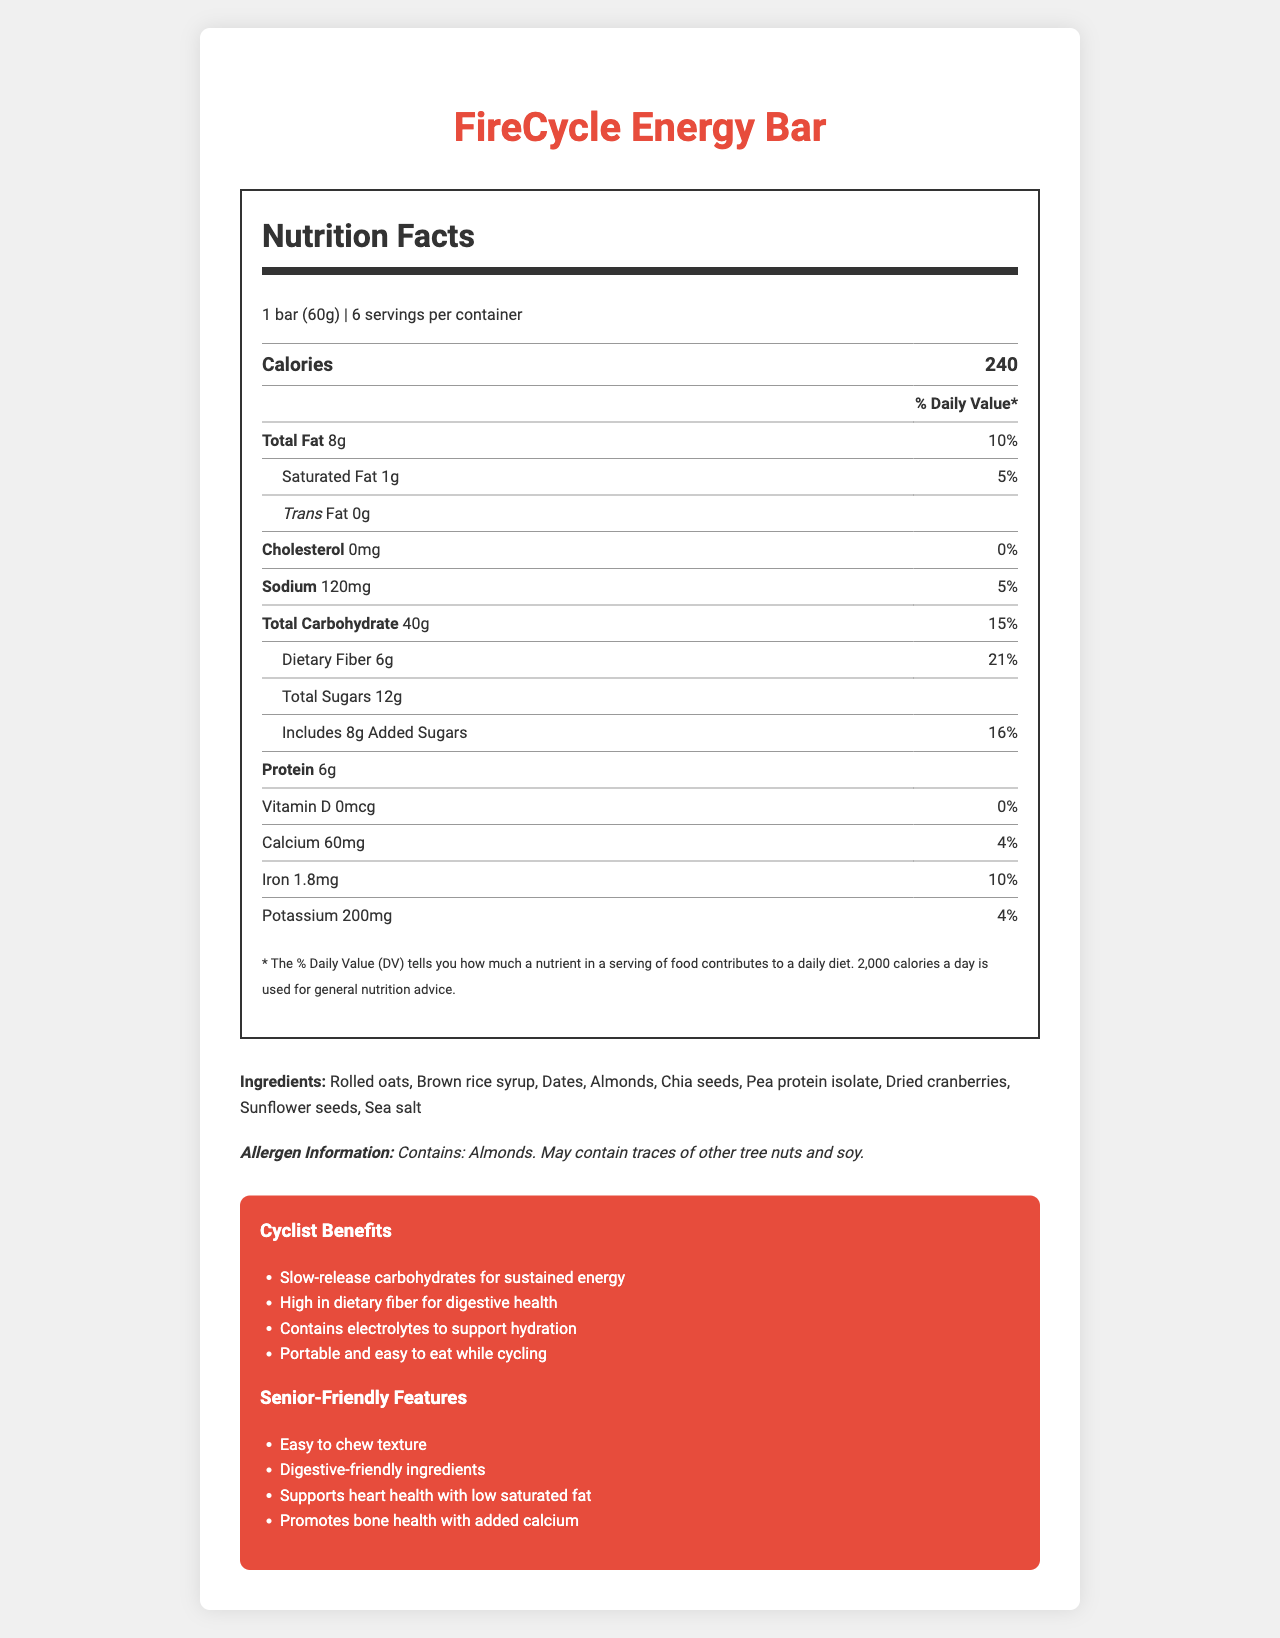what is the serving size for the FireCycle Energy Bar? The serving size is specified at the beginning of the Nutrition Facts section of the document.
Answer: 1 bar (60g) how many servings are in each FireCycle Energy Bar container? The document specifies that there are 6 servings per container.
Answer: 6 what is the total fat amount in one serving of the FireCycle Energy Bar? The total fat per serving is listed as 8g in the nutrition label.
Answer: 8g what percentage of the daily value of dietary fiber does one serving provide? The daily value percentage for dietary fiber is given as 21% in the nutrition label.
Answer: 21% list three main ingredients of the FireCycle Energy Bar. These are the first three ingredients listed in the ingredients section.
Answer: Rolled oats, Brown rice syrup, Dates what is the total carbohydrate content in one serving of the FireCycle Energy Bar? The total carbohydrate content is specified as 40g in the nutrition label.
Answer: 40g how many grams of added sugars are in one serving? The amount of added sugars is listed as 8g in the nutrition label.
Answer: 8g which nutrient in the FireCycle Energy Bar has the highest daily value percentage? A. Protein B. Calcium C. Dietary Fiber D. Iron The percentage daily value for dietary fiber is the highest at 21%.
Answer: C. Dietary Fiber which of the following is NOT an ingredient in the FireCycle Energy Bar? A. Almonds B. Quinoa C. Dates D. Sunflower seeds Quinoa is not listed among the ingredients; the other options are.
Answer: B. Quinoa is the FireCycle Energy Bar gluten-free? The document states that the product is gluten-free in the additional info section.
Answer: Yes does the FireCycle Energy Bar contain any cholesterol? The cholesterol amount is listed as 0mg, indicating there is no cholesterol in the product.
Answer: No summarize the main idea of the document. This summary captures all major sections—nutrition facts, ingredients, allergen info, and benefits—highlighted in the document.
Answer: The document provides detailed nutrition information about the FireCycle Energy Bar, which is a fiber-rich, slow-release carbohydrate snack optimized for long-distance cycling. It includes information about serving size, ingredients, allergen information, and specific benefits for cyclists and seniors. can this energy bar help with hydration during a long-distance cycling event? One of the cyclist benefits mentioned is that the bar contains electrolytes to support hydration, as stated in the additional info section.
Answer: Yes are there any allergens present in the FireCycle Energy Bar? The document mentions that the bar contains almonds and may contain traces of other tree nuts and soy.
Answer: Yes who is the manufacturer of the FireCycle Energy Bar? The manufacturer is listed at the end of the document under the storage instructions.
Answer: Retired Heroes Nutrition Co. how long does the product remain good after opening? The storage instructions specify that the product should be consumed within 3 days of opening.
Answer: 3 days what is the percentage daily value of iron in one serving? The iron daily value percentage is provided as 10% in the nutrition label.
Answer: 10% what is the low-glycemic index status of the FireCycle Energy Bar? The additional info section indicates that the product has a low glycemic index.
Answer: True does the document provide information about the exact release year of the FireCycle Energy Bar? The document does not contain any information regarding the release year of the product.
Answer: Cannot be determined 